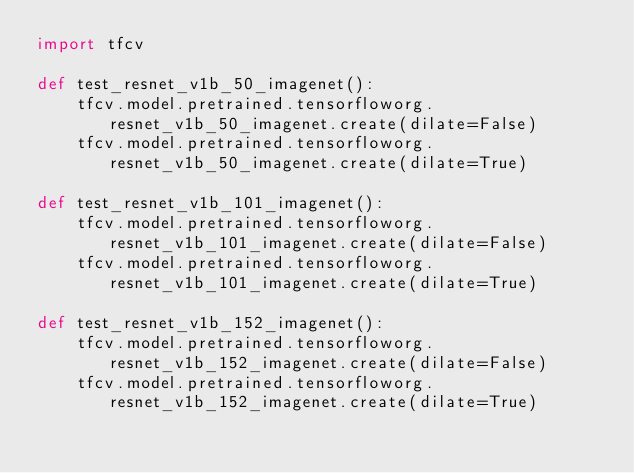Convert code to text. <code><loc_0><loc_0><loc_500><loc_500><_Python_>import tfcv

def test_resnet_v1b_50_imagenet():
    tfcv.model.pretrained.tensorfloworg.resnet_v1b_50_imagenet.create(dilate=False)
    tfcv.model.pretrained.tensorfloworg.resnet_v1b_50_imagenet.create(dilate=True)

def test_resnet_v1b_101_imagenet():
    tfcv.model.pretrained.tensorfloworg.resnet_v1b_101_imagenet.create(dilate=False)
    tfcv.model.pretrained.tensorfloworg.resnet_v1b_101_imagenet.create(dilate=True)

def test_resnet_v1b_152_imagenet():
    tfcv.model.pretrained.tensorfloworg.resnet_v1b_152_imagenet.create(dilate=False)
    tfcv.model.pretrained.tensorfloworg.resnet_v1b_152_imagenet.create(dilate=True)
</code> 